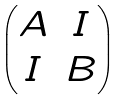<formula> <loc_0><loc_0><loc_500><loc_500>\begin{pmatrix} A & I \\ I & B \end{pmatrix}</formula> 